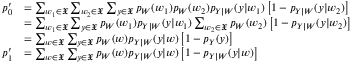Convert formula to latex. <formula><loc_0><loc_0><loc_500><loc_500>\begin{array} { r l } { p _ { 0 } ^ { \prime } } & { = \sum _ { w _ { 1 } \in \mathfrak { X } } \sum _ { w _ { 2 } \in \mathfrak { X } } \sum _ { y \in \mathfrak { X } } p _ { W } ( w _ { 1 } ) p _ { W } ( w _ { 2 } ) p _ { Y | W } ( y | w _ { 1 } ) \left [ 1 - p _ { Y | W } ( y | w _ { 2 } ) \right ] } \\ & { = \sum _ { w _ { 1 } \in \mathfrak { X } } \sum _ { y \in \mathfrak { X } } p _ { W } ( w _ { 1 } ) p _ { Y | W } ( y | w _ { 1 } ) \sum _ { w _ { 2 } \in \mathfrak { X } } p _ { W } ( w _ { 2 } ) \left [ 1 - p _ { Y | W } ( y | w _ { 2 } ) \right ] } \\ & { = \sum _ { w \in \mathfrak { X } } \sum _ { y \in \mathfrak { X } } p _ { W } ( w ) p _ { Y | W } ( y | w ) \left [ 1 - p _ { Y } ( y ) \right ] } \\ { p _ { 1 } ^ { \prime } } & { = \sum _ { w \in \mathfrak { X } } \sum _ { y \in \mathfrak { X } } p _ { W } ( w ) p _ { Y | W } ( y | w ) \left [ 1 - p _ { Y | W } ( y | w ) \right ] } \end{array}</formula> 